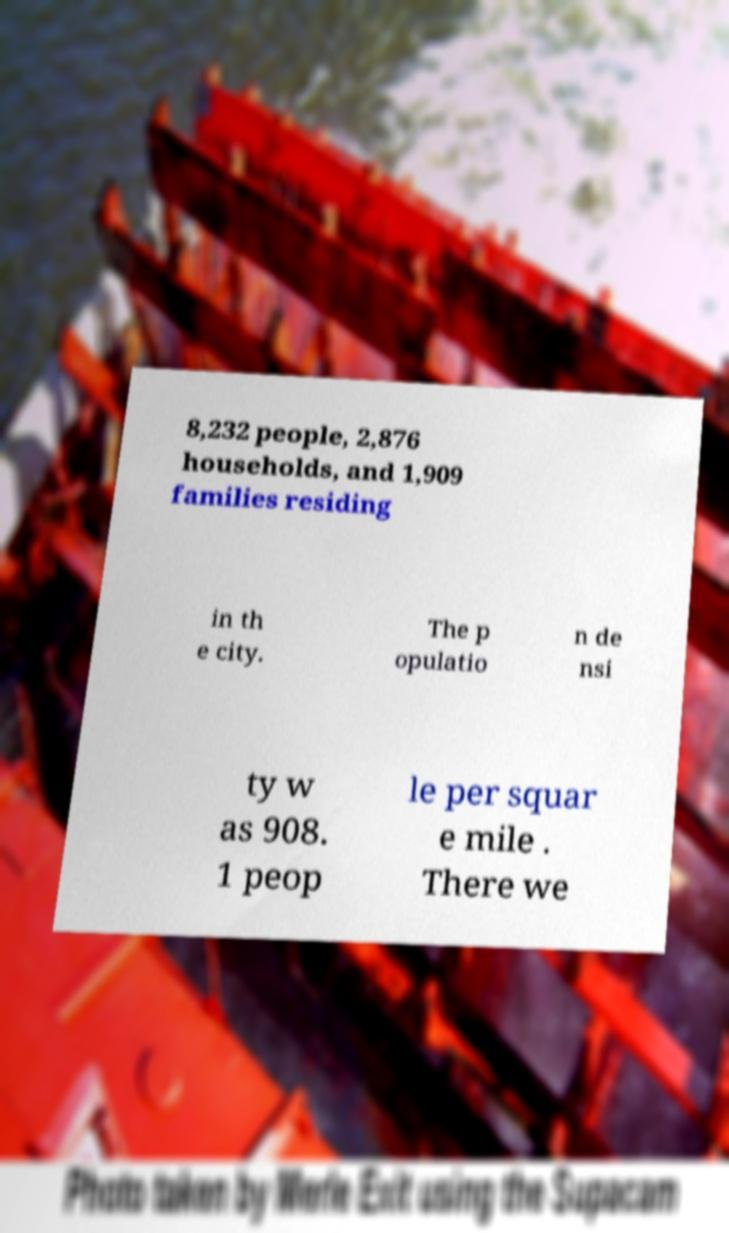Please identify and transcribe the text found in this image. 8,232 people, 2,876 households, and 1,909 families residing in th e city. The p opulatio n de nsi ty w as 908. 1 peop le per squar e mile . There we 